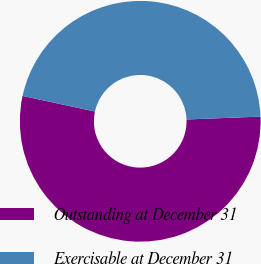Convert chart to OTSL. <chart><loc_0><loc_0><loc_500><loc_500><pie_chart><fcel>Outstanding at December 31<fcel>Exercisable at December 31<nl><fcel>54.0%<fcel>46.0%<nl></chart> 